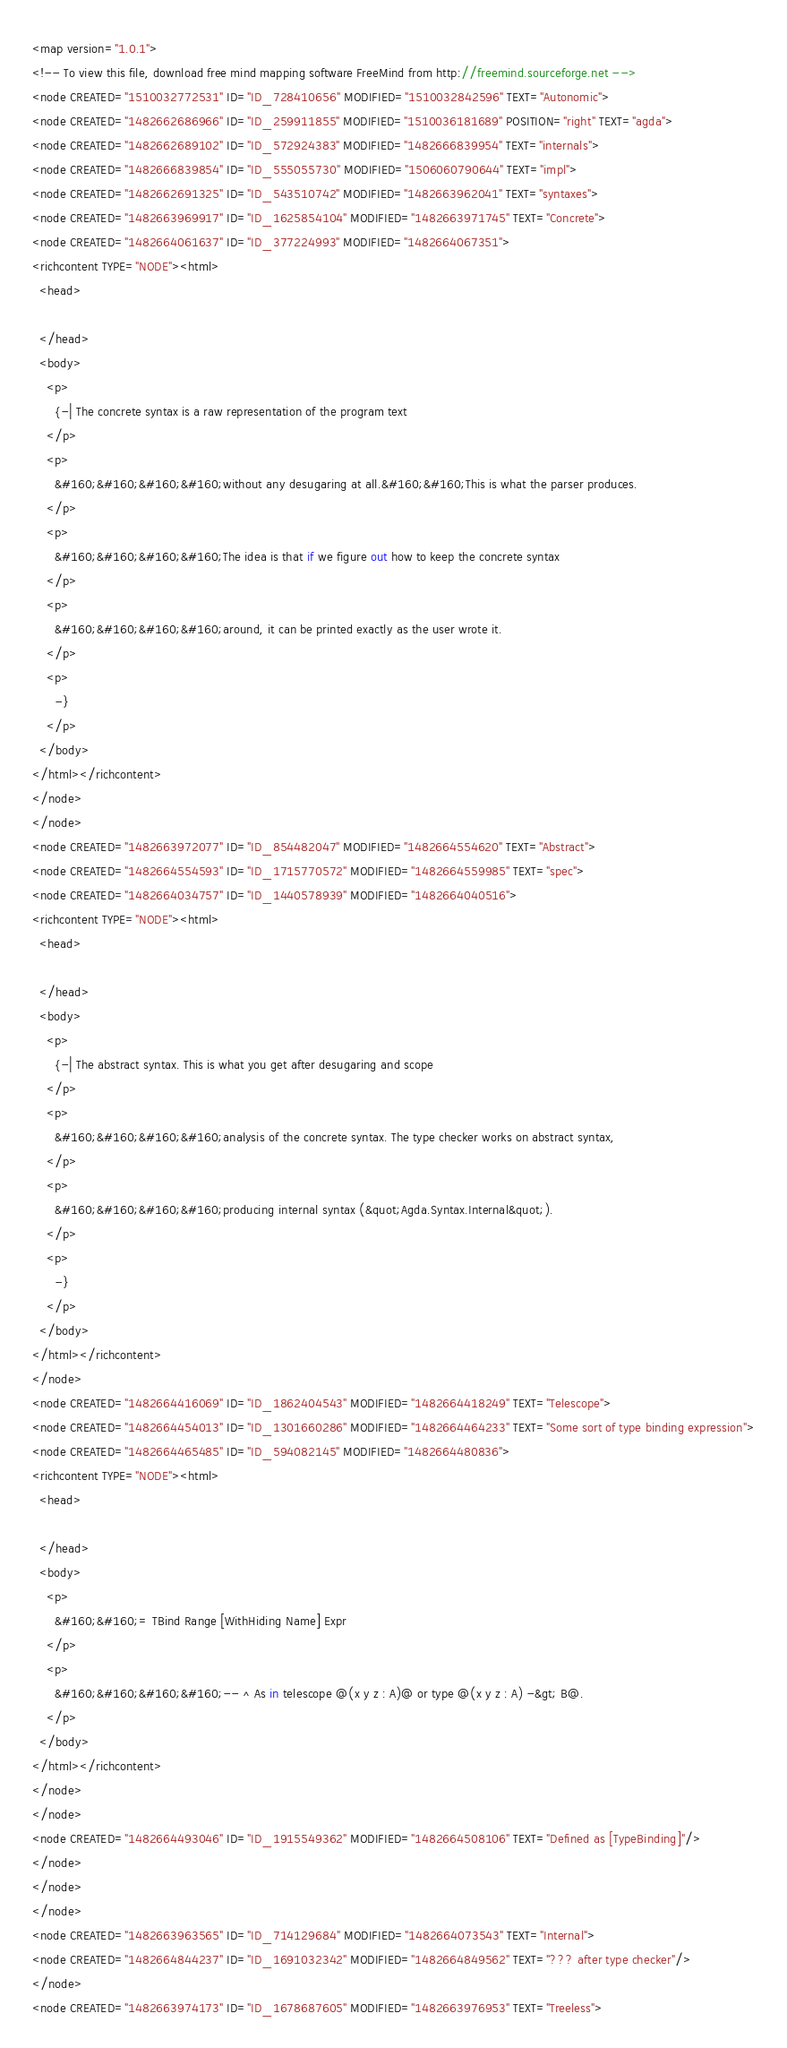<code> <loc_0><loc_0><loc_500><loc_500><_ObjectiveC_><map version="1.0.1">
<!-- To view this file, download free mind mapping software FreeMind from http://freemind.sourceforge.net -->
<node CREATED="1510032772531" ID="ID_728410656" MODIFIED="1510032842596" TEXT="Autonomic">
<node CREATED="1482662686966" ID="ID_259911855" MODIFIED="1510036181689" POSITION="right" TEXT="agda">
<node CREATED="1482662689102" ID="ID_572924383" MODIFIED="1482666839954" TEXT="internals">
<node CREATED="1482666839854" ID="ID_555055730" MODIFIED="1506060790644" TEXT="impl">
<node CREATED="1482662691325" ID="ID_543510742" MODIFIED="1482663962041" TEXT="syntaxes">
<node CREATED="1482663969917" ID="ID_1625854104" MODIFIED="1482663971745" TEXT="Concrete">
<node CREATED="1482664061637" ID="ID_377224993" MODIFIED="1482664067351">
<richcontent TYPE="NODE"><html>
  <head>
    
  </head>
  <body>
    <p>
      {-| The concrete syntax is a raw representation of the program text
    </p>
    <p>
      &#160;&#160;&#160;&#160;without any desugaring at all.&#160;&#160;This is what the parser produces.
    </p>
    <p>
      &#160;&#160;&#160;&#160;The idea is that if we figure out how to keep the concrete syntax
    </p>
    <p>
      &#160;&#160;&#160;&#160;around, it can be printed exactly as the user wrote it.
    </p>
    <p>
      -}
    </p>
  </body>
</html></richcontent>
</node>
</node>
<node CREATED="1482663972077" ID="ID_854482047" MODIFIED="1482664554620" TEXT="Abstract">
<node CREATED="1482664554593" ID="ID_1715770572" MODIFIED="1482664559985" TEXT="spec">
<node CREATED="1482664034757" ID="ID_1440578939" MODIFIED="1482664040516">
<richcontent TYPE="NODE"><html>
  <head>
    
  </head>
  <body>
    <p>
      {-| The abstract syntax. This is what you get after desugaring and scope
    </p>
    <p>
      &#160;&#160;&#160;&#160;analysis of the concrete syntax. The type checker works on abstract syntax,
    </p>
    <p>
      &#160;&#160;&#160;&#160;producing internal syntax (&quot;Agda.Syntax.Internal&quot;).
    </p>
    <p>
      -}
    </p>
  </body>
</html></richcontent>
</node>
<node CREATED="1482664416069" ID="ID_1862404543" MODIFIED="1482664418249" TEXT="Telescope">
<node CREATED="1482664454013" ID="ID_1301660286" MODIFIED="1482664464233" TEXT="Some sort of type binding expression">
<node CREATED="1482664465485" ID="ID_594082145" MODIFIED="1482664480836">
<richcontent TYPE="NODE"><html>
  <head>
    
  </head>
  <body>
    <p>
      &#160;&#160;= TBind Range [WithHiding Name] Expr
    </p>
    <p>
      &#160;&#160;&#160;&#160;-- ^ As in telescope @(x y z : A)@ or type @(x y z : A) -&gt; B@.
    </p>
  </body>
</html></richcontent>
</node>
</node>
<node CREATED="1482664493046" ID="ID_1915549362" MODIFIED="1482664508106" TEXT="Defined as [TypeBinding]"/>
</node>
</node>
</node>
<node CREATED="1482663963565" ID="ID_714129684" MODIFIED="1482664073543" TEXT="Internal">
<node CREATED="1482664844237" ID="ID_1691032342" MODIFIED="1482664849562" TEXT="??? after type checker"/>
</node>
<node CREATED="1482663974173" ID="ID_1678687605" MODIFIED="1482663976953" TEXT="Treeless"></code> 